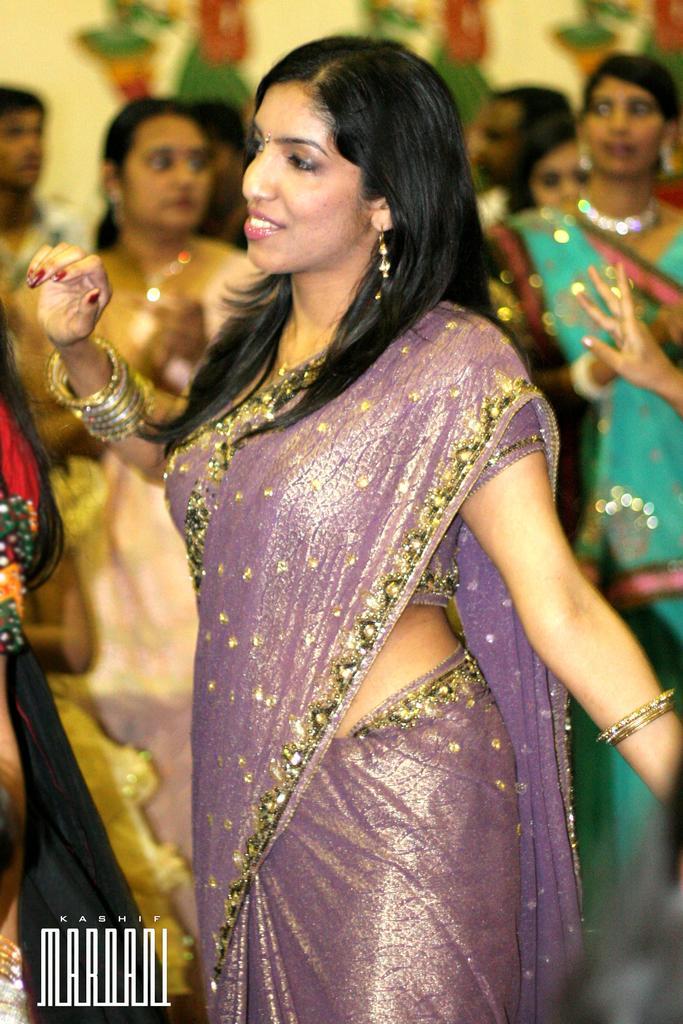Please provide a concise description of this image. In this image we can see there is a woman wearing saree is standing in the middle, beside her there are so many other buildings. 